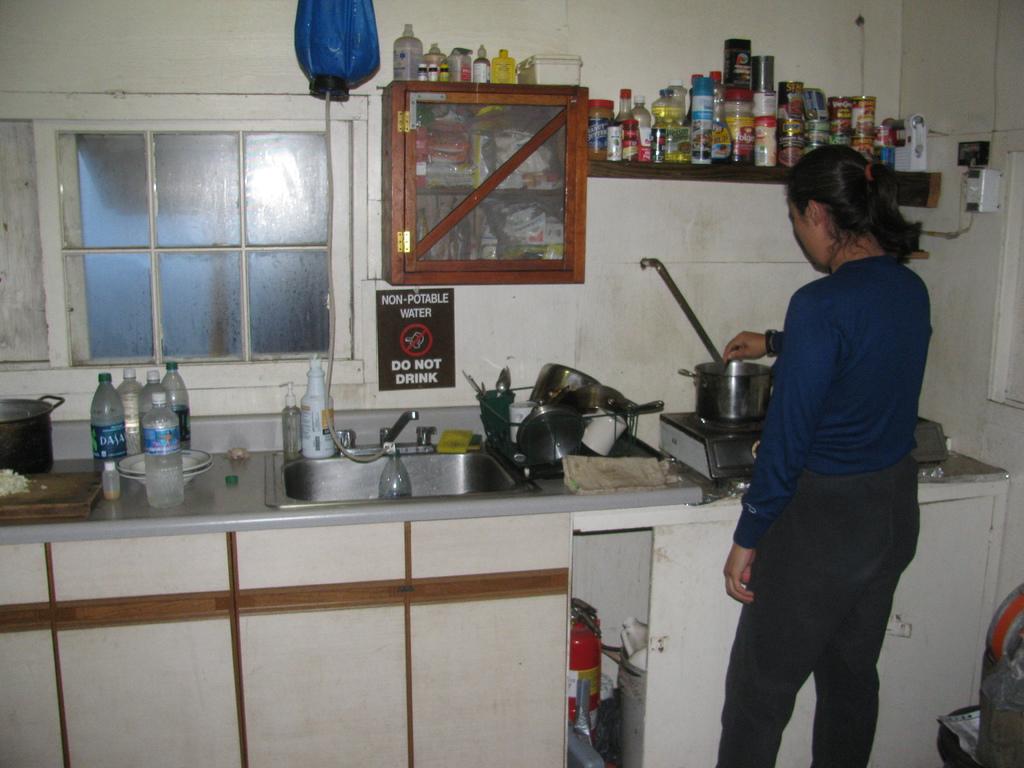What should you not drink?
Offer a terse response. Water. What brand is on the watter bottle on the left?
Your answer should be very brief. Dasani. 